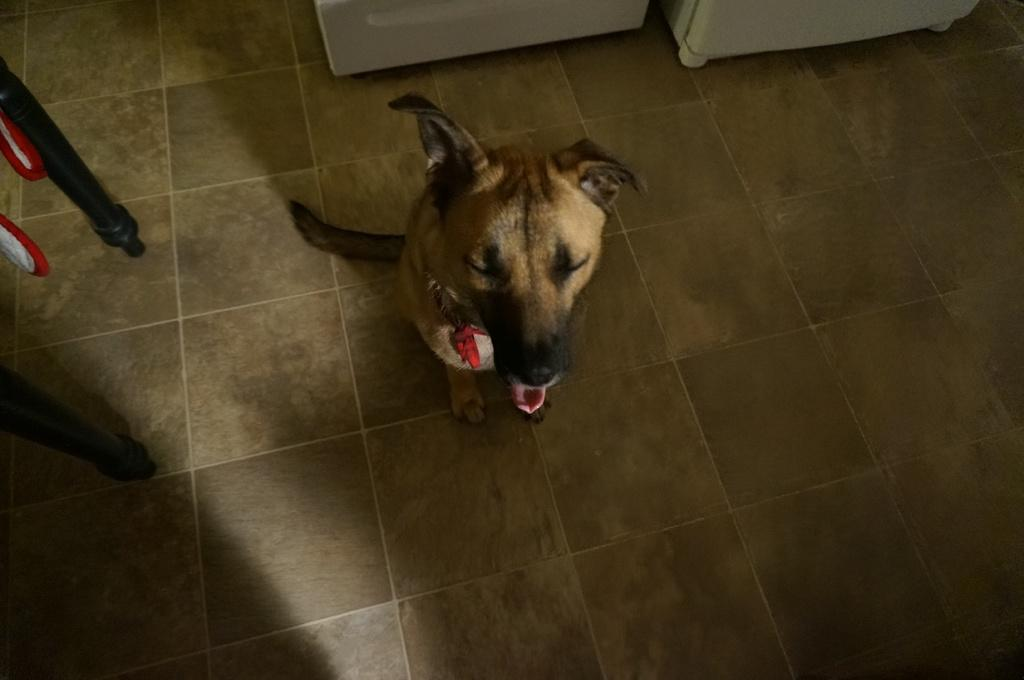What type of animal is present in the image? There is a dog in the image. What is the dog doing in the image? The dog appears to be sitting on the floor. What can be seen in the left corner of the image? There are metal rods in the left corner of the image. What else can be observed in the background of the image? There are other objects visible in the background of the image. Can you see a rake being used by the dog in the image? There is no rake present in the image, and the dog is not using any tool or object. 